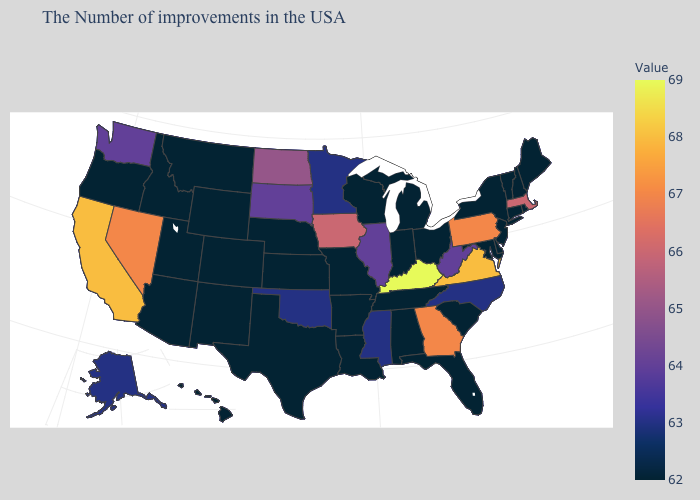Among the states that border Arkansas , which have the lowest value?
Write a very short answer. Tennessee, Louisiana, Missouri, Texas. Among the states that border Indiana , which have the lowest value?
Concise answer only. Ohio, Michigan. Does South Carolina have the lowest value in the USA?
Give a very brief answer. Yes. Does West Virginia have the highest value in the South?
Give a very brief answer. No. 